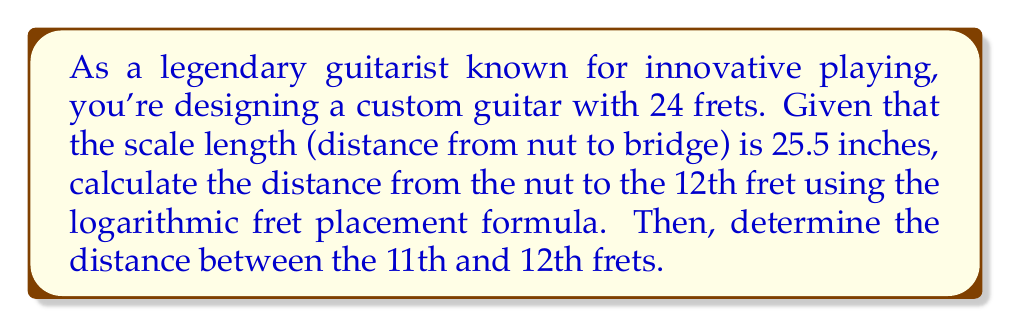Provide a solution to this math problem. To solve this problem, we'll use the logarithmic fret placement formula and follow these steps:

1) The formula for fret placement is:

   $$D_n = L(1 - 2^{-n/12})$$

   Where:
   $D_n$ is the distance from the nut to the nth fret
   $L$ is the scale length
   $n$ is the fret number

2) For the 12th fret, we have:
   $L = 25.5$ inches
   $n = 12$

3) Plugging these values into the formula:

   $$D_{12} = 25.5(1 - 2^{-12/12})$$
   $$D_{12} = 25.5(1 - 2^{-1})$$
   $$D_{12} = 25.5(1 - 0.5)$$
   $$D_{12} = 25.5 \times 0.5$$
   $$D_{12} = 12.75\text{ inches}$$

4) To find the distance between the 11th and 12th frets, we need to calculate the position of the 11th fret and subtract it from the 12th fret position:

   For the 11th fret:
   $$D_{11} = 25.5(1 - 2^{-11/12})$$
   $$D_{11} \approx 12.38\text{ inches}$$

5) The distance between the 11th and 12th frets is:
   $$12.75 - 12.38 = 0.37\text{ inches}$$
Answer: The distance from the nut to the 12th fret is 12.75 inches, and the distance between the 11th and 12th frets is 0.37 inches. 